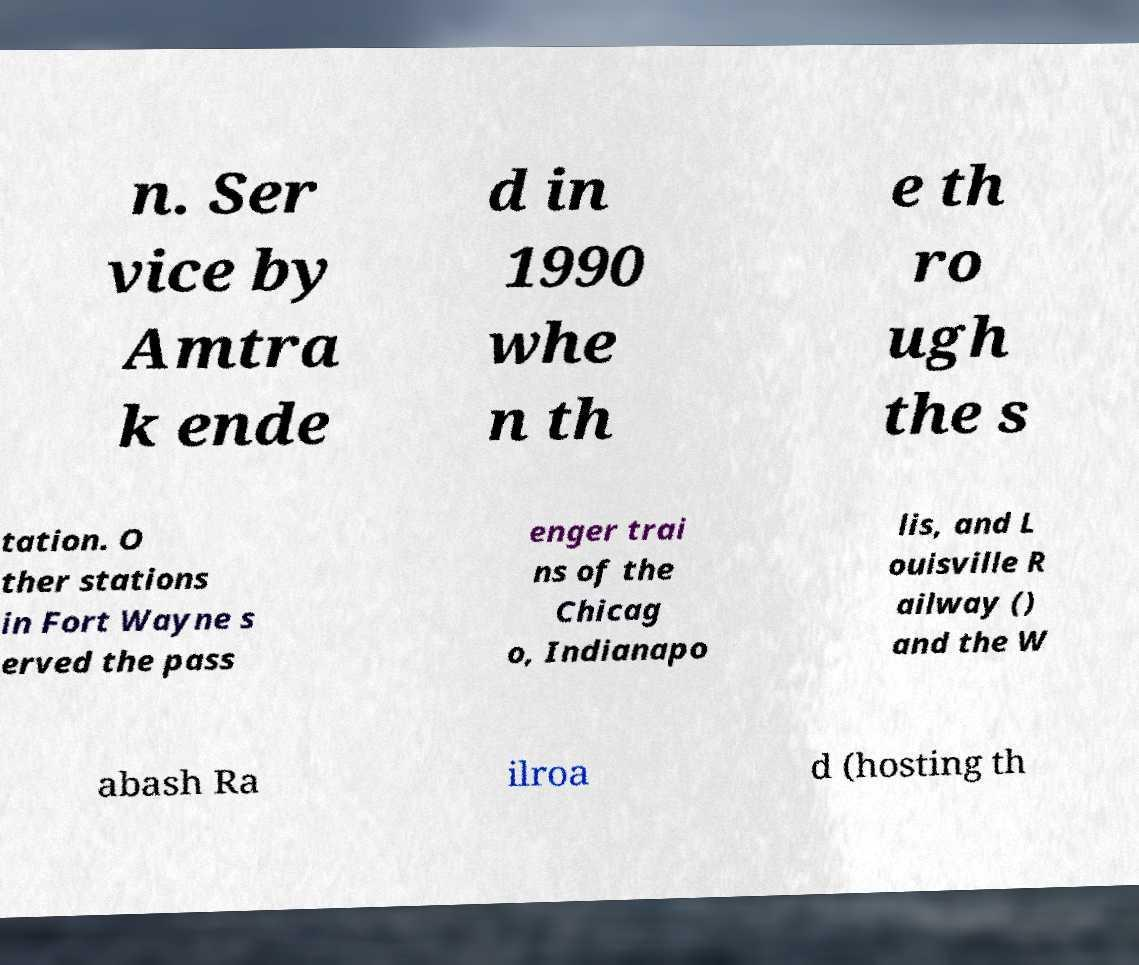I need the written content from this picture converted into text. Can you do that? n. Ser vice by Amtra k ende d in 1990 whe n th e th ro ugh the s tation. O ther stations in Fort Wayne s erved the pass enger trai ns of the Chicag o, Indianapo lis, and L ouisville R ailway () and the W abash Ra ilroa d (hosting th 